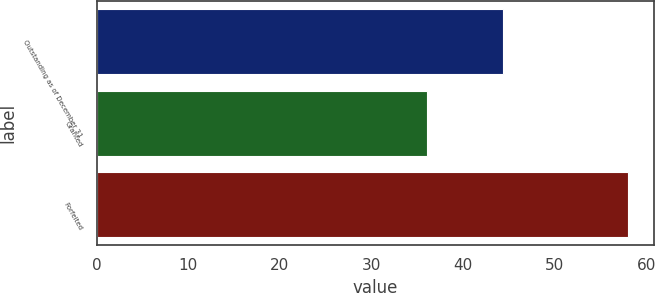Convert chart. <chart><loc_0><loc_0><loc_500><loc_500><bar_chart><fcel>Outstanding as of December 31<fcel>Granted<fcel>Forfeited<nl><fcel>44.38<fcel>36<fcel>57.94<nl></chart> 